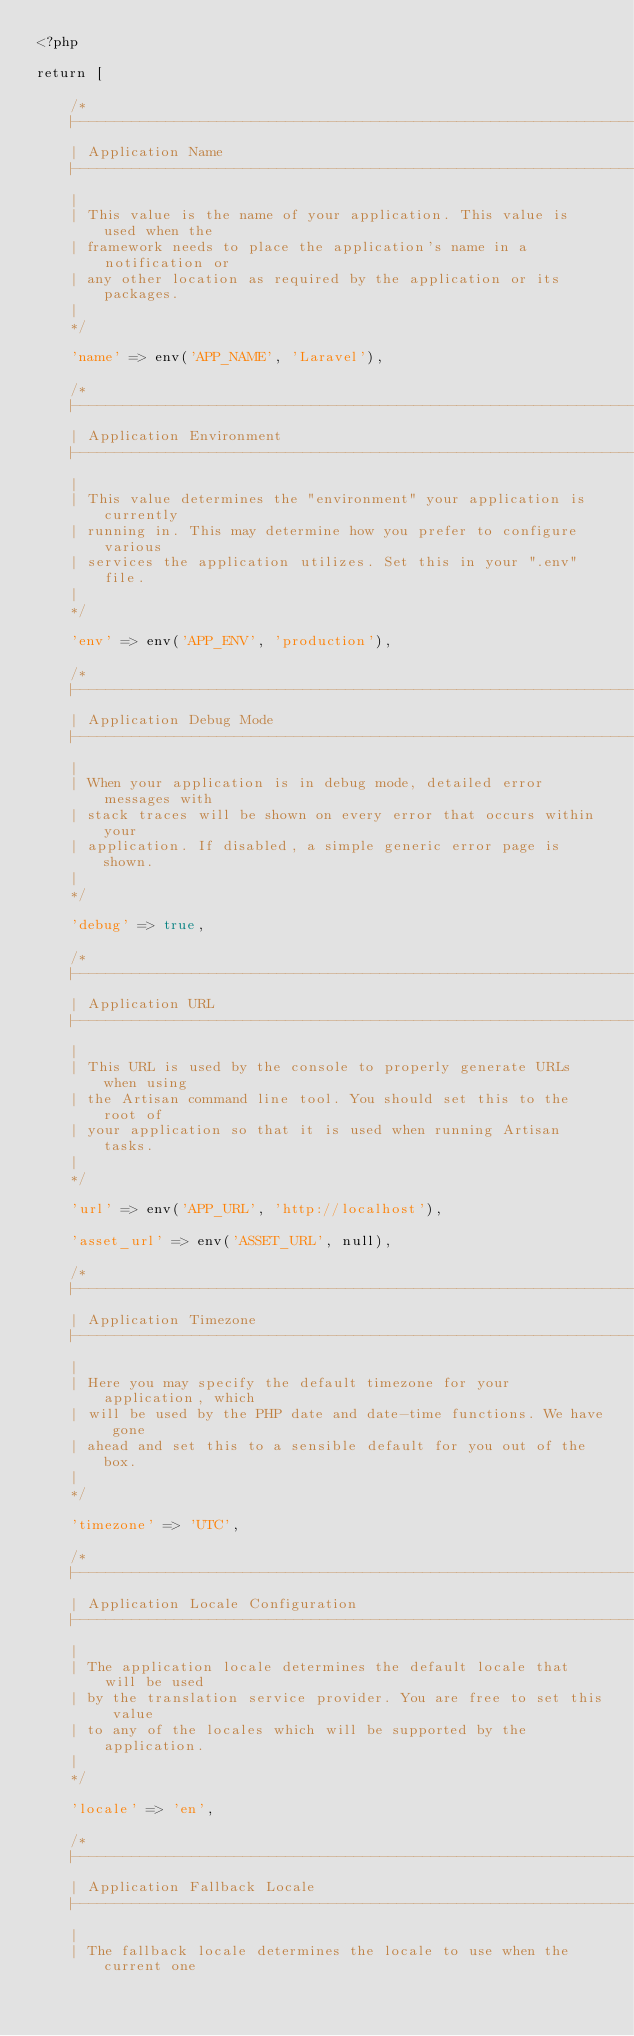<code> <loc_0><loc_0><loc_500><loc_500><_PHP_><?php

return [

    /*
    |--------------------------------------------------------------------------
    | Application Name
    |--------------------------------------------------------------------------
    |
    | This value is the name of your application. This value is used when the
    | framework needs to place the application's name in a notification or
    | any other location as required by the application or its packages.
    |
    */

    'name' => env('APP_NAME', 'Laravel'),

    /*
    |--------------------------------------------------------------------------
    | Application Environment
    |--------------------------------------------------------------------------
    |
    | This value determines the "environment" your application is currently
    | running in. This may determine how you prefer to configure various
    | services the application utilizes. Set this in your ".env" file.
    |
    */

    'env' => env('APP_ENV', 'production'),

    /*
    |--------------------------------------------------------------------------
    | Application Debug Mode
    |--------------------------------------------------------------------------
    |
    | When your application is in debug mode, detailed error messages with
    | stack traces will be shown on every error that occurs within your
    | application. If disabled, a simple generic error page is shown.
    |
    */

    'debug' => true,

    /*
    |--------------------------------------------------------------------------
    | Application URL
    |--------------------------------------------------------------------------
    |
    | This URL is used by the console to properly generate URLs when using
    | the Artisan command line tool. You should set this to the root of
    | your application so that it is used when running Artisan tasks.
    |
    */

    'url' => env('APP_URL', 'http://localhost'),

    'asset_url' => env('ASSET_URL', null),

    /*
    |--------------------------------------------------------------------------
    | Application Timezone
    |--------------------------------------------------------------------------
    |
    | Here you may specify the default timezone for your application, which
    | will be used by the PHP date and date-time functions. We have gone
    | ahead and set this to a sensible default for you out of the box.
    |
    */

    'timezone' => 'UTC',

    /*
    |--------------------------------------------------------------------------
    | Application Locale Configuration
    |--------------------------------------------------------------------------
    |
    | The application locale determines the default locale that will be used
    | by the translation service provider. You are free to set this value
    | to any of the locales which will be supported by the application.
    |
    */

    'locale' => 'en',

    /*
    |--------------------------------------------------------------------------
    | Application Fallback Locale
    |--------------------------------------------------------------------------
    |
    | The fallback locale determines the locale to use when the current one</code> 